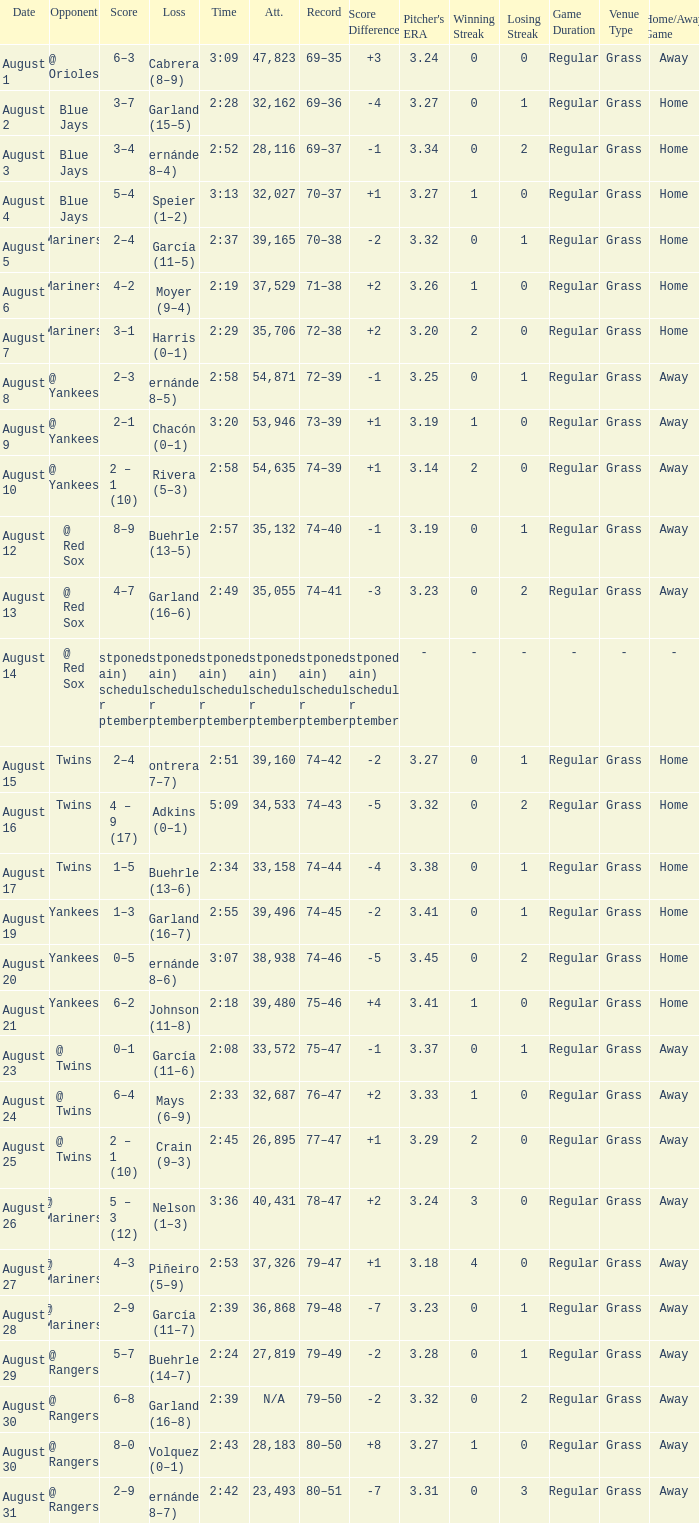Who lost with a time of 2:42? Hernández (8–7). 